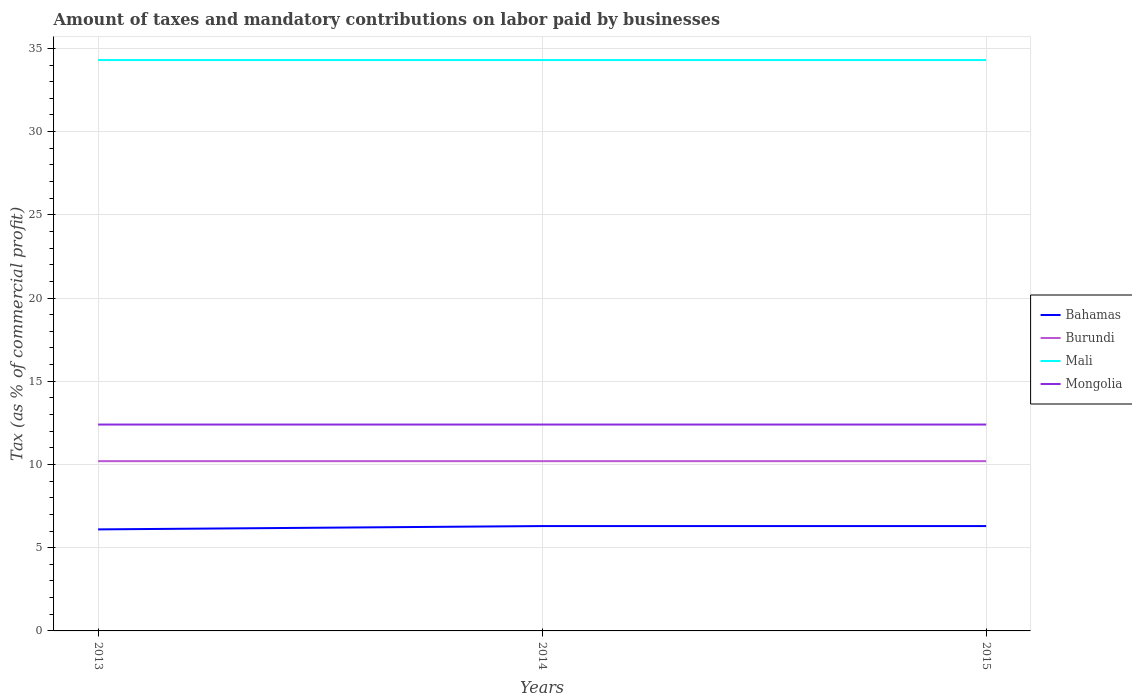How many different coloured lines are there?
Provide a succinct answer. 4. Does the line corresponding to Mongolia intersect with the line corresponding to Mali?
Keep it short and to the point. No. Is the number of lines equal to the number of legend labels?
Ensure brevity in your answer.  Yes. Across all years, what is the maximum percentage of taxes paid by businesses in Mali?
Offer a terse response. 34.3. In which year was the percentage of taxes paid by businesses in Burundi maximum?
Your answer should be very brief. 2013. What is the total percentage of taxes paid by businesses in Bahamas in the graph?
Make the answer very short. 0. What is the difference between two consecutive major ticks on the Y-axis?
Ensure brevity in your answer.  5. Are the values on the major ticks of Y-axis written in scientific E-notation?
Keep it short and to the point. No. Does the graph contain any zero values?
Make the answer very short. No. Where does the legend appear in the graph?
Keep it short and to the point. Center right. How are the legend labels stacked?
Ensure brevity in your answer.  Vertical. What is the title of the graph?
Provide a succinct answer. Amount of taxes and mandatory contributions on labor paid by businesses. Does "Iraq" appear as one of the legend labels in the graph?
Your answer should be compact. No. What is the label or title of the Y-axis?
Keep it short and to the point. Tax (as % of commercial profit). What is the Tax (as % of commercial profit) in Bahamas in 2013?
Keep it short and to the point. 6.1. What is the Tax (as % of commercial profit) in Burundi in 2013?
Ensure brevity in your answer.  10.2. What is the Tax (as % of commercial profit) of Mali in 2013?
Offer a terse response. 34.3. What is the Tax (as % of commercial profit) of Bahamas in 2014?
Ensure brevity in your answer.  6.3. What is the Tax (as % of commercial profit) of Mali in 2014?
Keep it short and to the point. 34.3. What is the Tax (as % of commercial profit) in Mongolia in 2014?
Provide a succinct answer. 12.4. What is the Tax (as % of commercial profit) in Bahamas in 2015?
Your response must be concise. 6.3. What is the Tax (as % of commercial profit) of Mali in 2015?
Ensure brevity in your answer.  34.3. What is the Tax (as % of commercial profit) of Mongolia in 2015?
Make the answer very short. 12.4. Across all years, what is the maximum Tax (as % of commercial profit) of Mali?
Make the answer very short. 34.3. Across all years, what is the maximum Tax (as % of commercial profit) of Mongolia?
Give a very brief answer. 12.4. Across all years, what is the minimum Tax (as % of commercial profit) of Mali?
Make the answer very short. 34.3. Across all years, what is the minimum Tax (as % of commercial profit) of Mongolia?
Your answer should be compact. 12.4. What is the total Tax (as % of commercial profit) in Bahamas in the graph?
Offer a terse response. 18.7. What is the total Tax (as % of commercial profit) of Burundi in the graph?
Provide a short and direct response. 30.6. What is the total Tax (as % of commercial profit) of Mali in the graph?
Your answer should be very brief. 102.9. What is the total Tax (as % of commercial profit) in Mongolia in the graph?
Your response must be concise. 37.2. What is the difference between the Tax (as % of commercial profit) of Mali in 2013 and that in 2014?
Your answer should be compact. 0. What is the difference between the Tax (as % of commercial profit) in Mongolia in 2013 and that in 2014?
Offer a terse response. 0. What is the difference between the Tax (as % of commercial profit) of Mali in 2013 and that in 2015?
Your answer should be very brief. 0. What is the difference between the Tax (as % of commercial profit) of Burundi in 2014 and that in 2015?
Your response must be concise. 0. What is the difference between the Tax (as % of commercial profit) in Mali in 2014 and that in 2015?
Your answer should be compact. 0. What is the difference between the Tax (as % of commercial profit) in Bahamas in 2013 and the Tax (as % of commercial profit) in Burundi in 2014?
Offer a very short reply. -4.1. What is the difference between the Tax (as % of commercial profit) in Bahamas in 2013 and the Tax (as % of commercial profit) in Mali in 2014?
Your response must be concise. -28.2. What is the difference between the Tax (as % of commercial profit) in Bahamas in 2013 and the Tax (as % of commercial profit) in Mongolia in 2014?
Provide a short and direct response. -6.3. What is the difference between the Tax (as % of commercial profit) in Burundi in 2013 and the Tax (as % of commercial profit) in Mali in 2014?
Your response must be concise. -24.1. What is the difference between the Tax (as % of commercial profit) in Mali in 2013 and the Tax (as % of commercial profit) in Mongolia in 2014?
Provide a short and direct response. 21.9. What is the difference between the Tax (as % of commercial profit) in Bahamas in 2013 and the Tax (as % of commercial profit) in Mali in 2015?
Your answer should be compact. -28.2. What is the difference between the Tax (as % of commercial profit) of Burundi in 2013 and the Tax (as % of commercial profit) of Mali in 2015?
Make the answer very short. -24.1. What is the difference between the Tax (as % of commercial profit) of Burundi in 2013 and the Tax (as % of commercial profit) of Mongolia in 2015?
Ensure brevity in your answer.  -2.2. What is the difference between the Tax (as % of commercial profit) of Mali in 2013 and the Tax (as % of commercial profit) of Mongolia in 2015?
Provide a succinct answer. 21.9. What is the difference between the Tax (as % of commercial profit) of Bahamas in 2014 and the Tax (as % of commercial profit) of Mongolia in 2015?
Provide a succinct answer. -6.1. What is the difference between the Tax (as % of commercial profit) of Burundi in 2014 and the Tax (as % of commercial profit) of Mali in 2015?
Provide a short and direct response. -24.1. What is the difference between the Tax (as % of commercial profit) of Burundi in 2014 and the Tax (as % of commercial profit) of Mongolia in 2015?
Keep it short and to the point. -2.2. What is the difference between the Tax (as % of commercial profit) in Mali in 2014 and the Tax (as % of commercial profit) in Mongolia in 2015?
Provide a succinct answer. 21.9. What is the average Tax (as % of commercial profit) of Bahamas per year?
Your answer should be compact. 6.23. What is the average Tax (as % of commercial profit) in Burundi per year?
Offer a terse response. 10.2. What is the average Tax (as % of commercial profit) of Mali per year?
Your answer should be compact. 34.3. In the year 2013, what is the difference between the Tax (as % of commercial profit) in Bahamas and Tax (as % of commercial profit) in Burundi?
Give a very brief answer. -4.1. In the year 2013, what is the difference between the Tax (as % of commercial profit) in Bahamas and Tax (as % of commercial profit) in Mali?
Your response must be concise. -28.2. In the year 2013, what is the difference between the Tax (as % of commercial profit) of Burundi and Tax (as % of commercial profit) of Mali?
Offer a terse response. -24.1. In the year 2013, what is the difference between the Tax (as % of commercial profit) in Mali and Tax (as % of commercial profit) in Mongolia?
Make the answer very short. 21.9. In the year 2014, what is the difference between the Tax (as % of commercial profit) of Bahamas and Tax (as % of commercial profit) of Mali?
Provide a short and direct response. -28. In the year 2014, what is the difference between the Tax (as % of commercial profit) of Bahamas and Tax (as % of commercial profit) of Mongolia?
Your answer should be very brief. -6.1. In the year 2014, what is the difference between the Tax (as % of commercial profit) of Burundi and Tax (as % of commercial profit) of Mali?
Offer a very short reply. -24.1. In the year 2014, what is the difference between the Tax (as % of commercial profit) of Mali and Tax (as % of commercial profit) of Mongolia?
Your answer should be compact. 21.9. In the year 2015, what is the difference between the Tax (as % of commercial profit) in Bahamas and Tax (as % of commercial profit) in Mali?
Your answer should be compact. -28. In the year 2015, what is the difference between the Tax (as % of commercial profit) of Bahamas and Tax (as % of commercial profit) of Mongolia?
Your answer should be very brief. -6.1. In the year 2015, what is the difference between the Tax (as % of commercial profit) in Burundi and Tax (as % of commercial profit) in Mali?
Provide a short and direct response. -24.1. In the year 2015, what is the difference between the Tax (as % of commercial profit) of Mali and Tax (as % of commercial profit) of Mongolia?
Offer a terse response. 21.9. What is the ratio of the Tax (as % of commercial profit) of Bahamas in 2013 to that in 2014?
Provide a short and direct response. 0.97. What is the ratio of the Tax (as % of commercial profit) in Burundi in 2013 to that in 2014?
Your response must be concise. 1. What is the ratio of the Tax (as % of commercial profit) of Mali in 2013 to that in 2014?
Provide a short and direct response. 1. What is the ratio of the Tax (as % of commercial profit) in Bahamas in 2013 to that in 2015?
Make the answer very short. 0.97. What is the ratio of the Tax (as % of commercial profit) of Burundi in 2013 to that in 2015?
Your response must be concise. 1. What is the ratio of the Tax (as % of commercial profit) in Burundi in 2014 to that in 2015?
Provide a succinct answer. 1. What is the difference between the highest and the second highest Tax (as % of commercial profit) in Bahamas?
Ensure brevity in your answer.  0. 